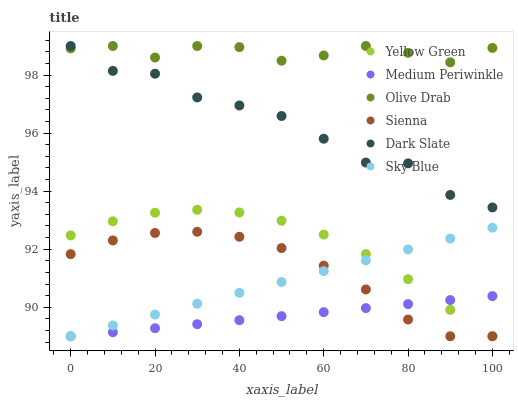Does Medium Periwinkle have the minimum area under the curve?
Answer yes or no. Yes. Does Olive Drab have the maximum area under the curve?
Answer yes or no. Yes. Does Sienna have the minimum area under the curve?
Answer yes or no. No. Does Sienna have the maximum area under the curve?
Answer yes or no. No. Is Sky Blue the smoothest?
Answer yes or no. Yes. Is Dark Slate the roughest?
Answer yes or no. Yes. Is Medium Periwinkle the smoothest?
Answer yes or no. No. Is Medium Periwinkle the roughest?
Answer yes or no. No. Does Yellow Green have the lowest value?
Answer yes or no. Yes. Does Dark Slate have the lowest value?
Answer yes or no. No. Does Olive Drab have the highest value?
Answer yes or no. Yes. Does Sienna have the highest value?
Answer yes or no. No. Is Yellow Green less than Dark Slate?
Answer yes or no. Yes. Is Olive Drab greater than Yellow Green?
Answer yes or no. Yes. Does Dark Slate intersect Olive Drab?
Answer yes or no. Yes. Is Dark Slate less than Olive Drab?
Answer yes or no. No. Is Dark Slate greater than Olive Drab?
Answer yes or no. No. Does Yellow Green intersect Dark Slate?
Answer yes or no. No. 